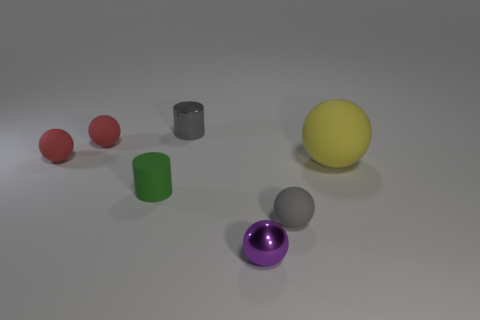There is a shiny thing that is behind the small gray matte object; are there any red things that are on the right side of it?
Offer a terse response. No. What color is the shiny sphere that is the same size as the green matte cylinder?
Make the answer very short. Purple. How many objects are cyan matte spheres or small red spheres?
Give a very brief answer. 2. There is a metal object that is behind the gray thing right of the tiny metallic cylinder that is behind the yellow rubber sphere; what size is it?
Keep it short and to the point. Small. What number of objects are the same color as the matte cylinder?
Your response must be concise. 0. How many gray things have the same material as the green thing?
Keep it short and to the point. 1. How many objects are red rubber objects or small shiny objects in front of the big yellow matte sphere?
Give a very brief answer. 3. The small ball that is to the right of the tiny metal thing in front of the cylinder that is behind the large matte sphere is what color?
Give a very brief answer. Gray. What is the size of the gray thing in front of the big matte sphere?
Offer a very short reply. Small. How many big objects are either red rubber things or matte spheres?
Keep it short and to the point. 1. 